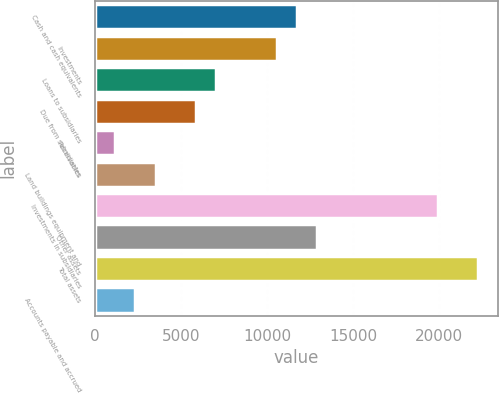<chart> <loc_0><loc_0><loc_500><loc_500><bar_chart><fcel>Cash and cash equivalents<fcel>Investments<fcel>Loans to subsidiaries<fcel>Due from subsidiaries<fcel>Receivables<fcel>Land buildings equipment and<fcel>Investments in subsidiaries<fcel>Other assets<fcel>Total assets<fcel>Accounts payable and accrued<nl><fcel>11731<fcel>10558.2<fcel>7039.8<fcel>5867<fcel>1175.8<fcel>3521.4<fcel>19940.6<fcel>12903.8<fcel>22286.2<fcel>2348.6<nl></chart> 